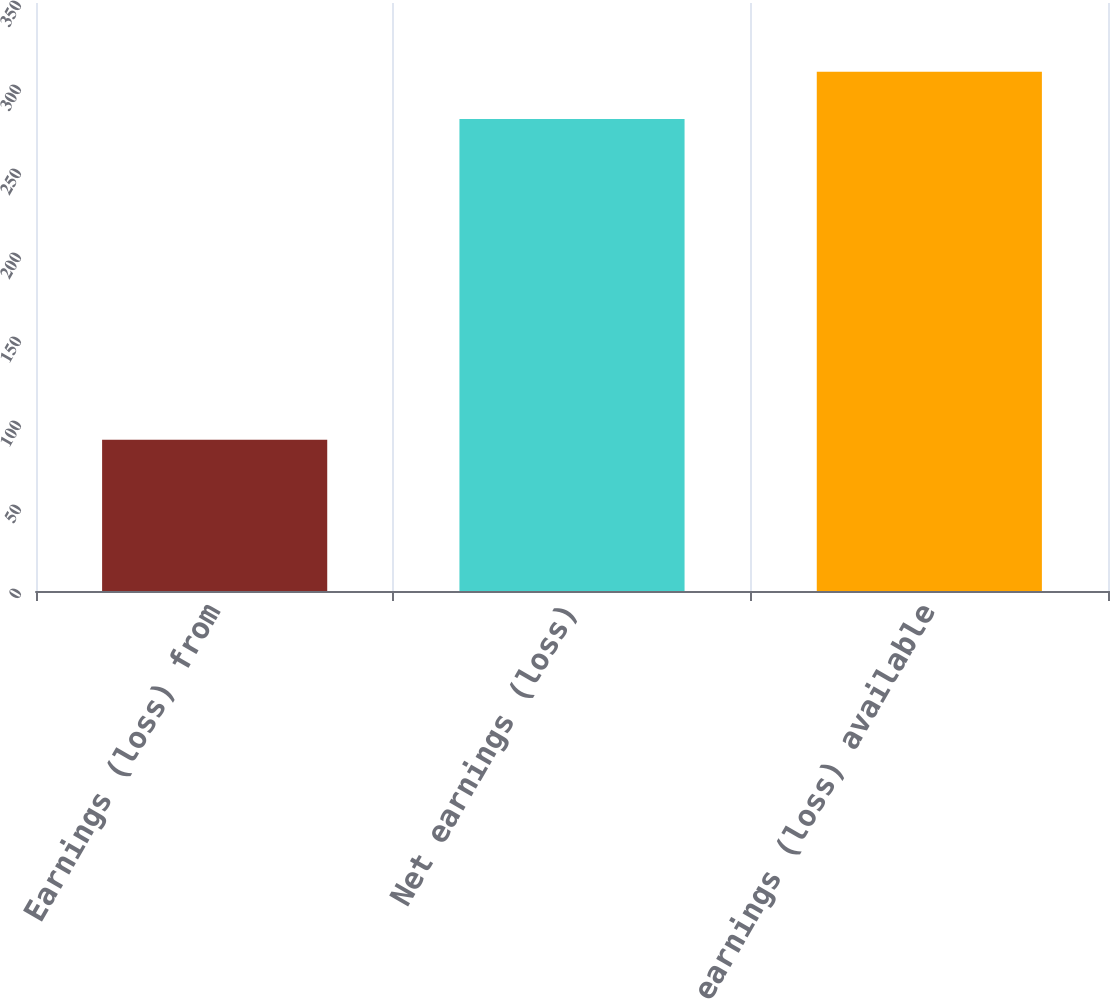<chart> <loc_0><loc_0><loc_500><loc_500><bar_chart><fcel>Earnings (loss) from<fcel>Net earnings (loss)<fcel>Net earnings (loss) available<nl><fcel>90<fcel>281<fcel>309.1<nl></chart> 